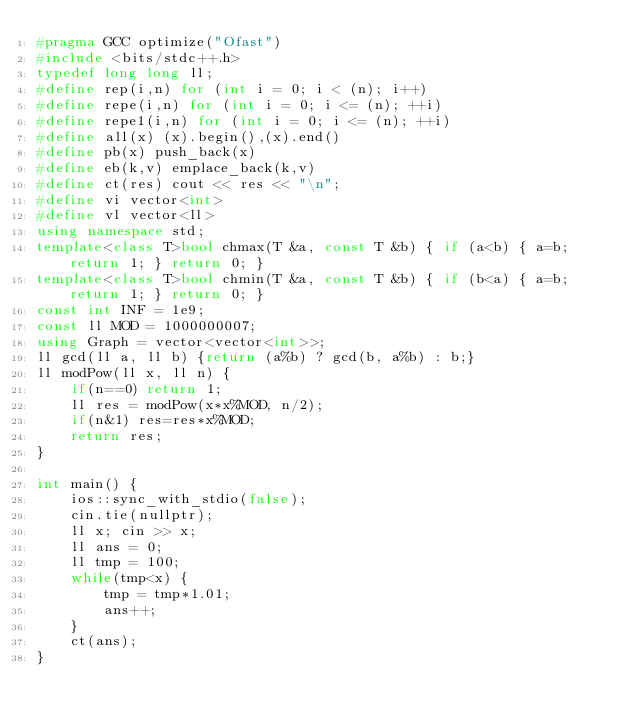<code> <loc_0><loc_0><loc_500><loc_500><_C++_>#pragma GCC optimize("Ofast")
#include <bits/stdc++.h>
typedef long long ll;
#define rep(i,n) for (int i = 0; i < (n); i++)
#define repe(i,n) for (int i = 0; i <= (n); ++i)
#define repe1(i,n) for (int i = 0; i <= (n); ++i)
#define all(x) (x).begin(),(x).end()
#define pb(x) push_back(x)
#define eb(k,v) emplace_back(k,v)
#define ct(res) cout << res << "\n";
#define vi vector<int>
#define vl vector<ll>
using namespace std;
template<class T>bool chmax(T &a, const T &b) { if (a<b) { a=b; return 1; } return 0; }
template<class T>bool chmin(T &a, const T &b) { if (b<a) { a=b; return 1; } return 0; }
const int INF = 1e9;
const ll MOD = 1000000007;
using Graph = vector<vector<int>>;
ll gcd(ll a, ll b) {return (a%b) ? gcd(b, a%b) : b;}
ll modPow(ll x, ll n) {
    if(n==0) return 1;
    ll res = modPow(x*x%MOD, n/2);
    if(n&1) res=res*x%MOD;
    return res;
}

int main() {
    ios::sync_with_stdio(false);
    cin.tie(nullptr);
    ll x; cin >> x;
    ll ans = 0;
    ll tmp = 100;
    while(tmp<x) {
        tmp = tmp*1.01;
        ans++;
    }
    ct(ans);
}
</code> 